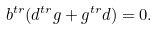<formula> <loc_0><loc_0><loc_500><loc_500>b ^ { t r } ( d ^ { t r } g + g ^ { t r } d ) = 0 .</formula> 